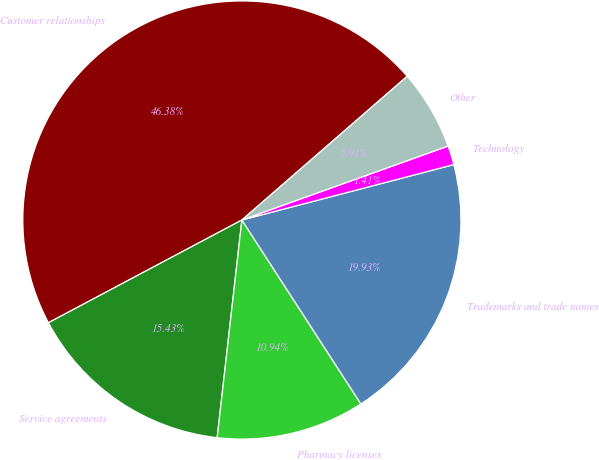Convert chart. <chart><loc_0><loc_0><loc_500><loc_500><pie_chart><fcel>Customer relationships<fcel>Service agreements<fcel>Pharmacy licenses<fcel>Trademarks and trade names<fcel>Technology<fcel>Other<nl><fcel>46.38%<fcel>15.43%<fcel>10.94%<fcel>19.93%<fcel>1.41%<fcel>5.91%<nl></chart> 